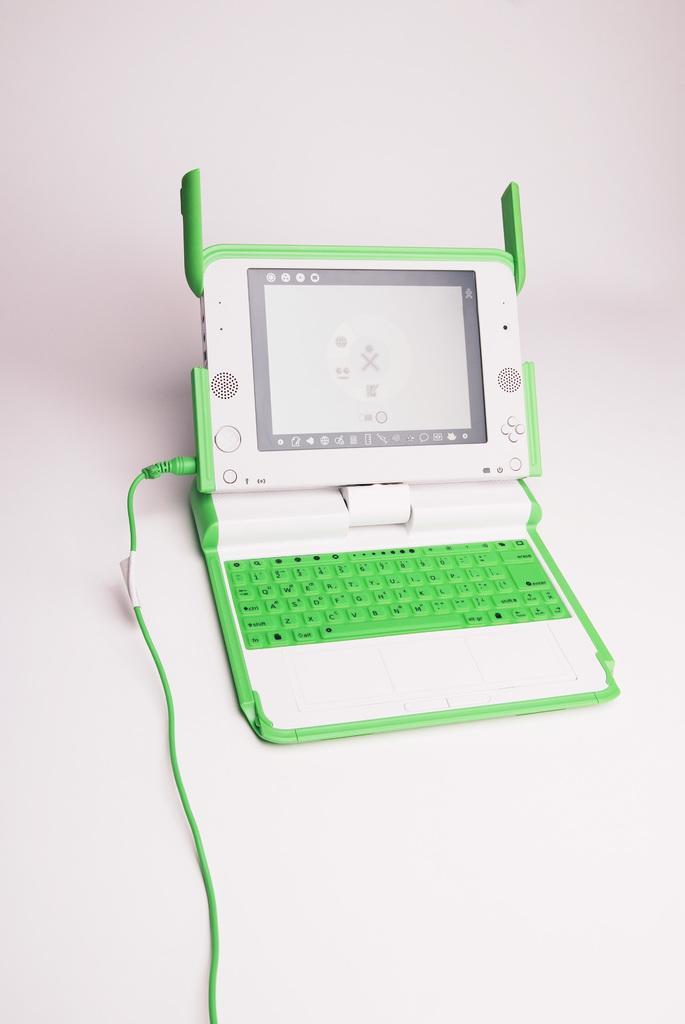Describe this image in one or two sentences. In this image we can see a device with keyboard, screen, buttons and cable is placed on the surface. 